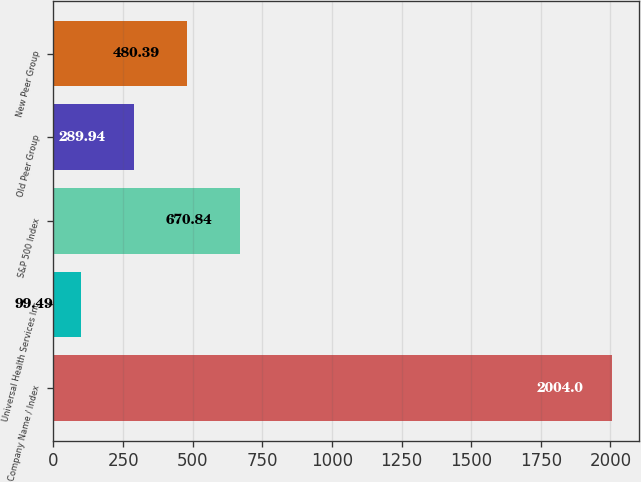Convert chart. <chart><loc_0><loc_0><loc_500><loc_500><bar_chart><fcel>Company Name / Index<fcel>Universal Health Services Inc<fcel>S&P 500 Index<fcel>Old Peer Group<fcel>New Peer Group<nl><fcel>2004<fcel>99.49<fcel>670.84<fcel>289.94<fcel>480.39<nl></chart> 